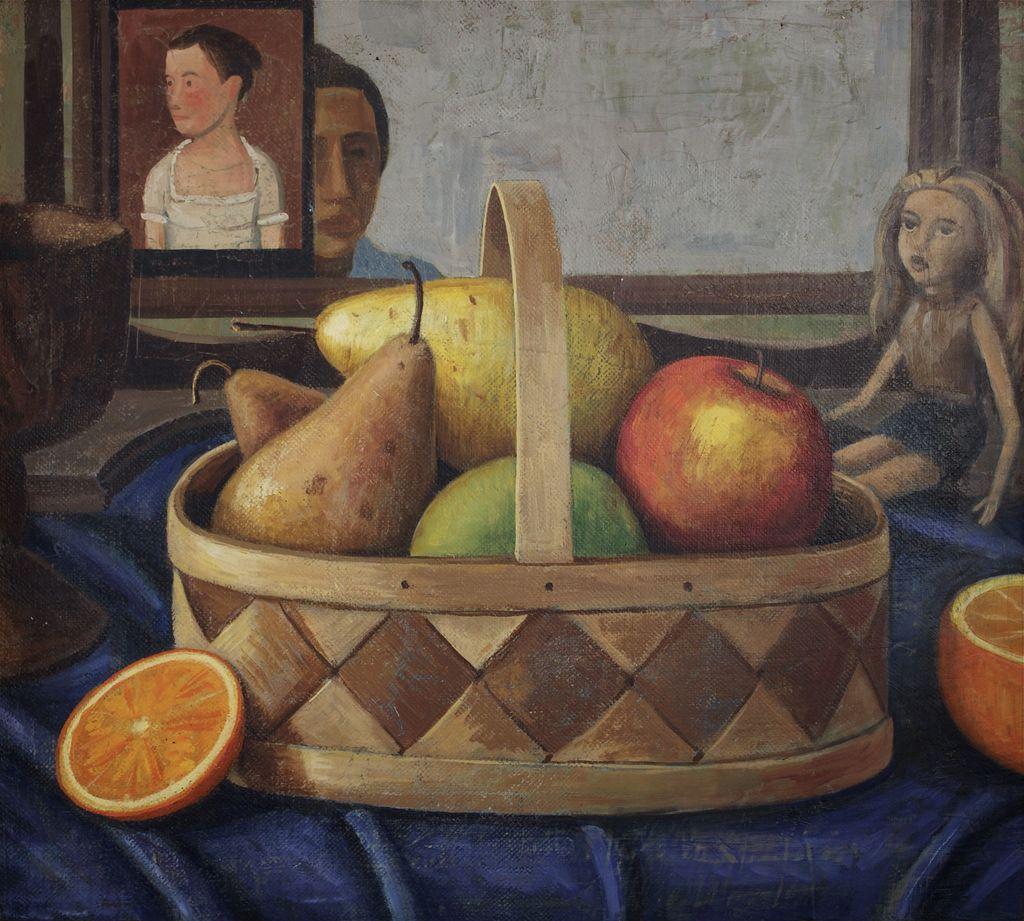Please provide a concise description of this image. This picture looks like a painting. On the table we can see wooden basket and oranges. In the basket we can see apples, mango and other fruits. On the left there is a girl. She is sitting on the bench. Here we can see a projector screen and a photo frame. 